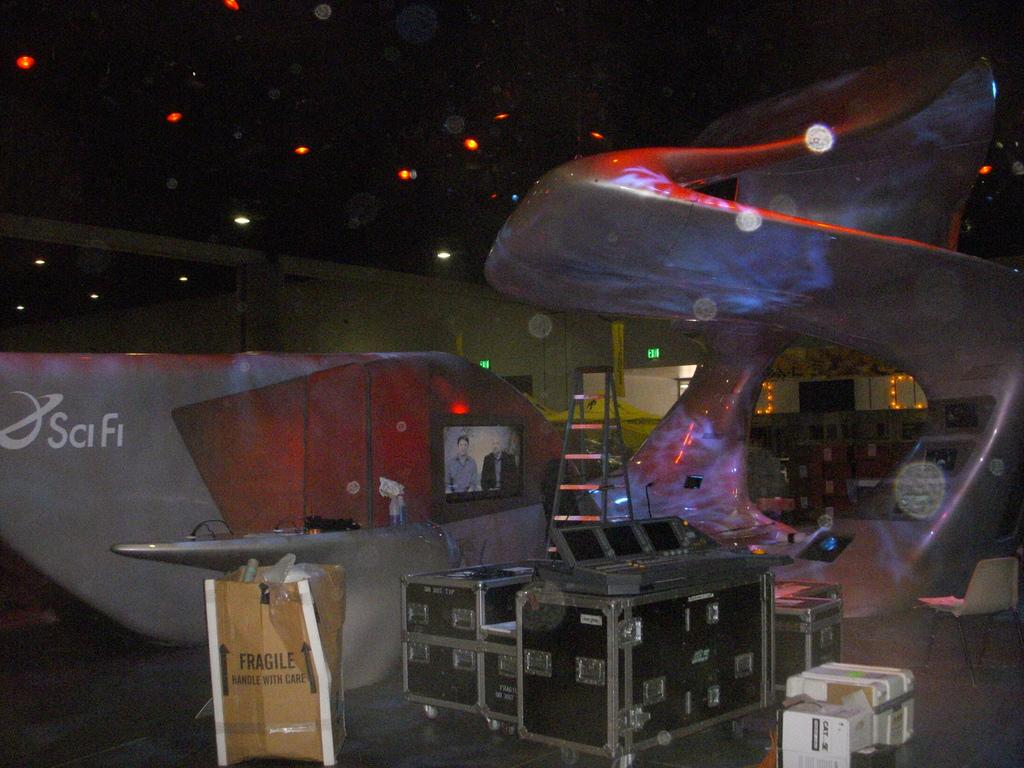What objects can be seen in the image? There are a few boxes and a television in the image. What type of lighting is present in the image? There are lights attached to the ceiling in the image. What is the background of the image? There is a wall in the backdrop of the image. Is there a stranger in the image adjusting the school's schedule? There is no stranger or reference to a school's schedule in the image. 